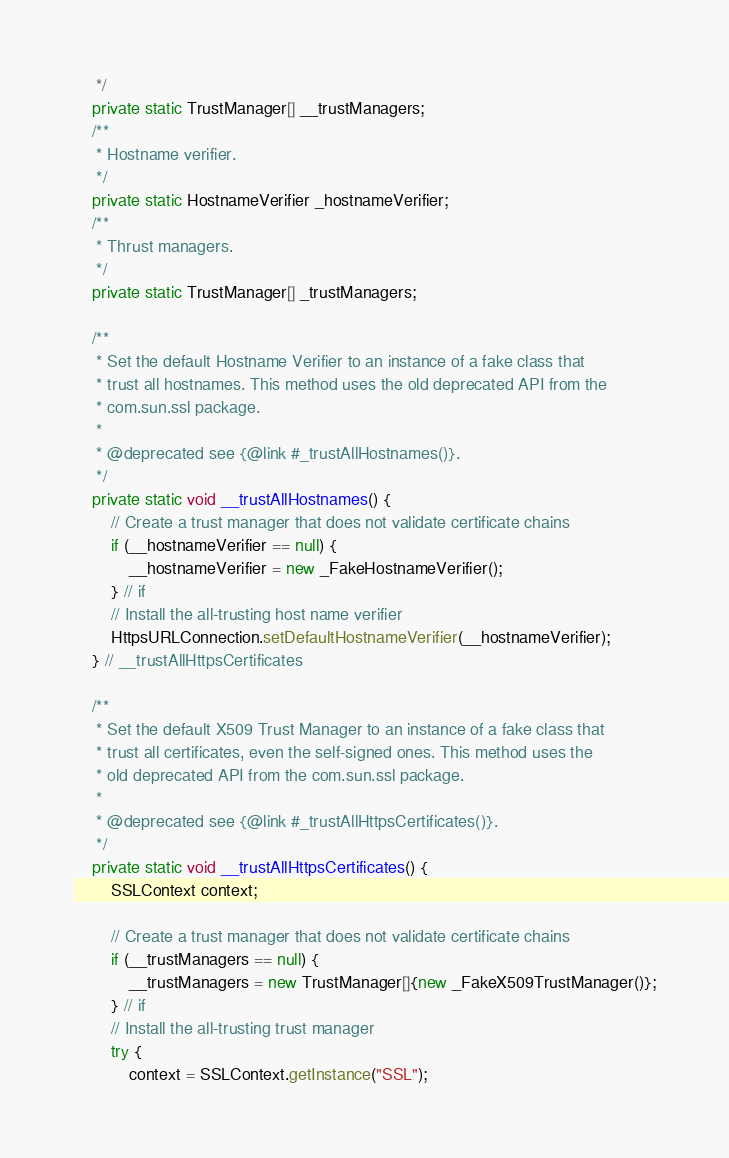Convert code to text. <code><loc_0><loc_0><loc_500><loc_500><_Java_>     */
    private static TrustManager[] __trustManagers;
    /**
     * Hostname verifier.
     */
    private static HostnameVerifier _hostnameVerifier;
    /**
     * Thrust managers.
     */
    private static TrustManager[] _trustManagers;

    /**
     * Set the default Hostname Verifier to an instance of a fake class that
     * trust all hostnames. This method uses the old deprecated API from the
     * com.sun.ssl package.
     *
     * @deprecated see {@link #_trustAllHostnames()}.
     */
    private static void __trustAllHostnames() {
        // Create a trust manager that does not validate certificate chains
        if (__hostnameVerifier == null) {
            __hostnameVerifier = new _FakeHostnameVerifier();
        } // if
        // Install the all-trusting host name verifier
        HttpsURLConnection.setDefaultHostnameVerifier(__hostnameVerifier);
    } // __trustAllHttpsCertificates

    /**
     * Set the default X509 Trust Manager to an instance of a fake class that
     * trust all certificates, even the self-signed ones. This method uses the
     * old deprecated API from the com.sun.ssl package.
     *
     * @deprecated see {@link #_trustAllHttpsCertificates()}.
     */
    private static void __trustAllHttpsCertificates() {
        SSLContext context;

        // Create a trust manager that does not validate certificate chains
        if (__trustManagers == null) {
            __trustManagers = new TrustManager[]{new _FakeX509TrustManager()};
        } // if
        // Install the all-trusting trust manager
        try {
            context = SSLContext.getInstance("SSL");</code> 